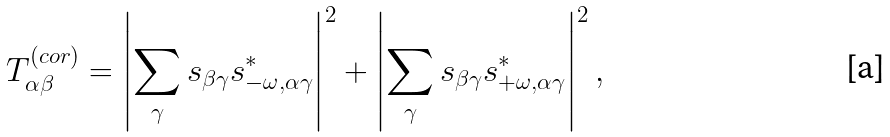Convert formula to latex. <formula><loc_0><loc_0><loc_500><loc_500>T _ { \alpha \beta } ^ { ( c o r ) } = \left | \sum _ { \gamma } s _ { \beta \gamma } s ^ { * } _ { - \omega , \alpha \gamma } \right | ^ { 2 } + \left | \sum _ { \gamma } s _ { \beta \gamma } s ^ { * } _ { + \omega , \alpha \gamma } \right | ^ { 2 } ,</formula> 